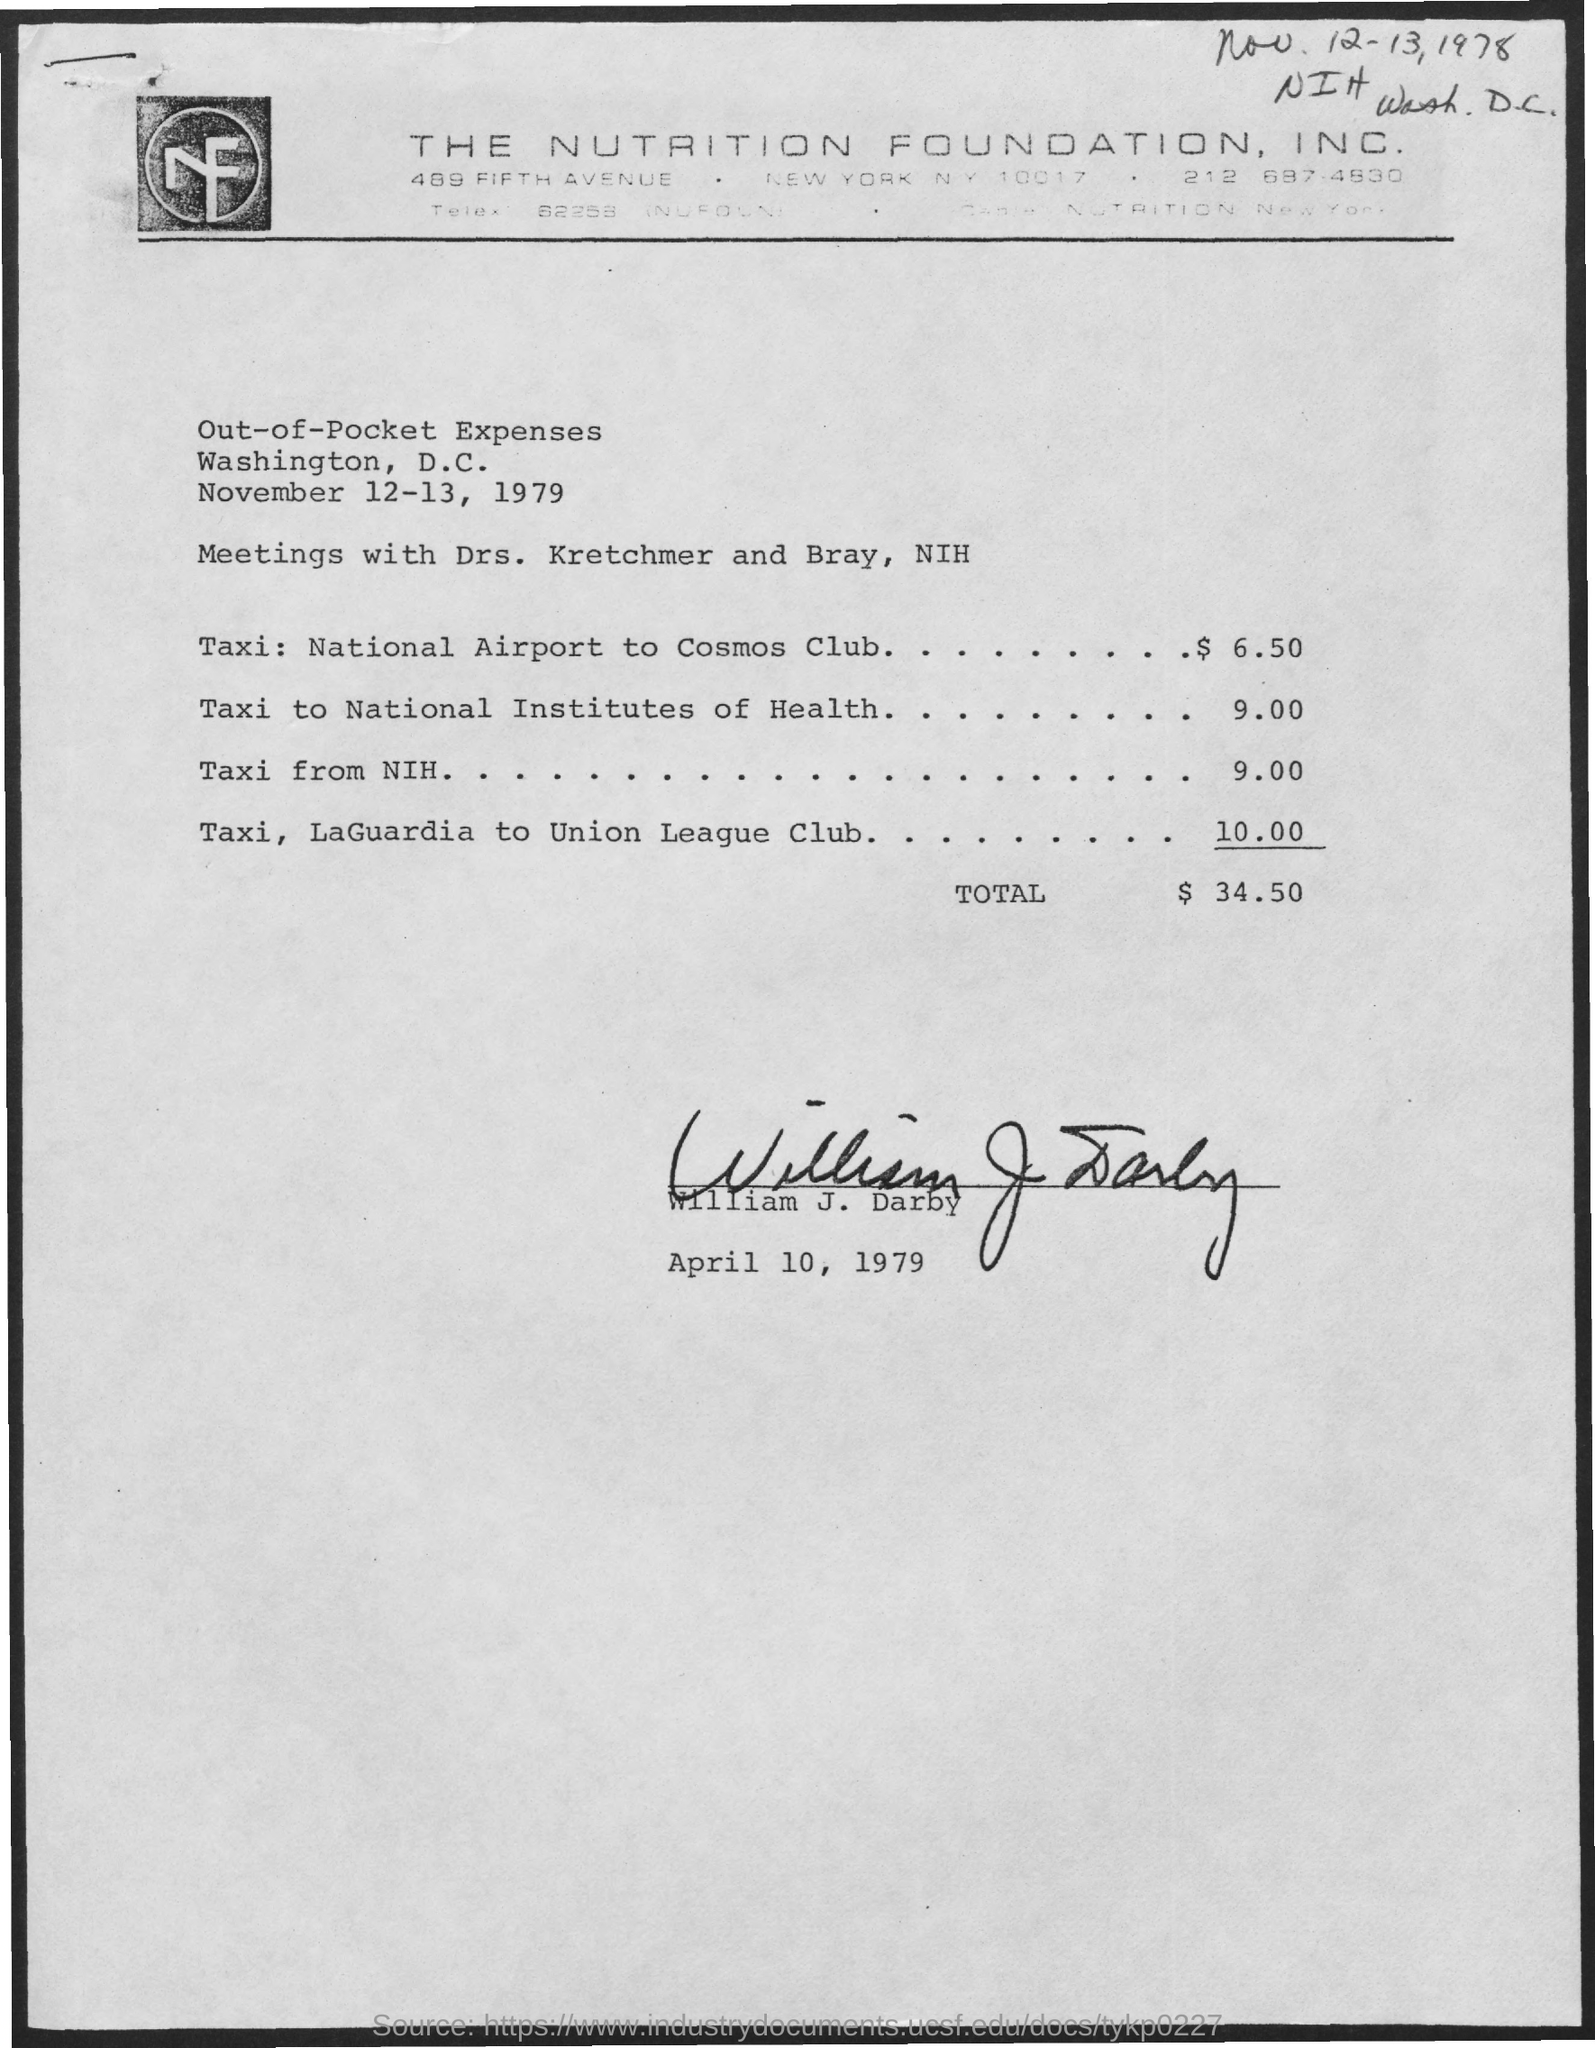This  expense sheet is given by whom ?
Your response must be concise. William J. Darby. What is the total amount ?
Your answer should be very brief. $ 34.50. What is the cost of taxi from taxi from nih ?
Offer a very short reply. $ 9.00. What is the cost of taxi , from laguardia to union league club?
Offer a terse response. 10.00. What is the taxi price from national airport to cosmos club ?
Give a very brief answer. $ 6.50. In which city the nutrition foundation . located ?
Offer a terse response. New york. 